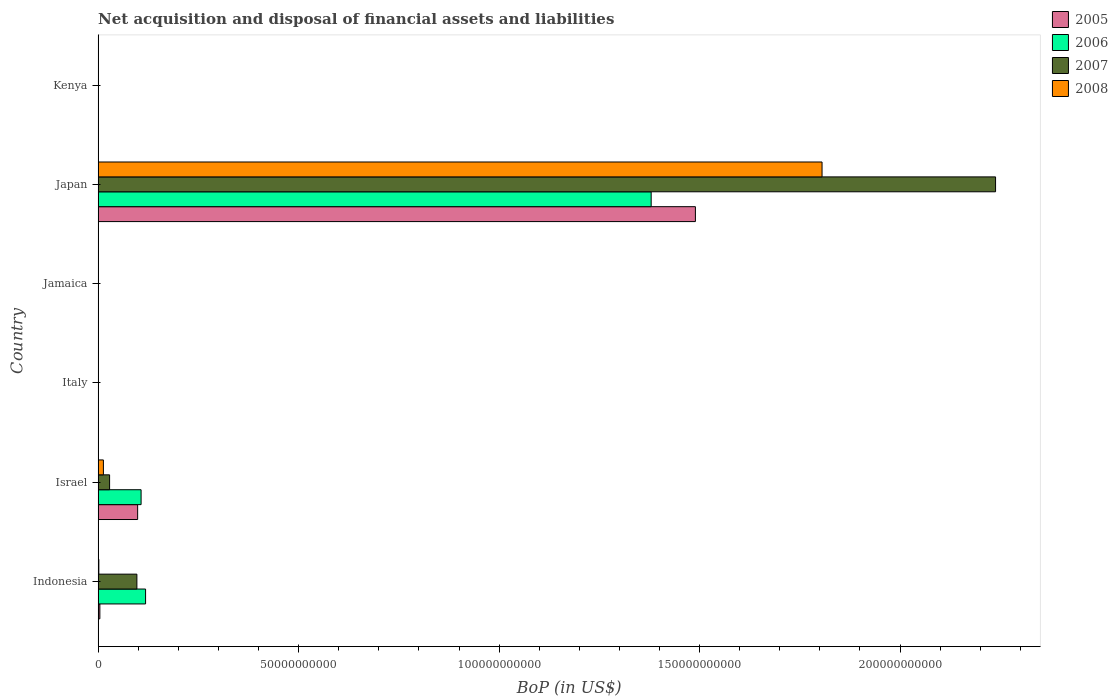How many different coloured bars are there?
Make the answer very short. 4. Are the number of bars on each tick of the Y-axis equal?
Make the answer very short. No. How many bars are there on the 2nd tick from the top?
Your answer should be compact. 4. What is the Balance of Payments in 2008 in Japan?
Make the answer very short. 1.81e+11. Across all countries, what is the maximum Balance of Payments in 2006?
Ensure brevity in your answer.  1.38e+11. Across all countries, what is the minimum Balance of Payments in 2006?
Provide a succinct answer. 0. In which country was the Balance of Payments in 2005 maximum?
Make the answer very short. Japan. What is the total Balance of Payments in 2007 in the graph?
Give a very brief answer. 2.36e+11. What is the difference between the Balance of Payments in 2006 in Israel and that in Japan?
Your answer should be very brief. -1.27e+11. What is the difference between the Balance of Payments in 2007 in Japan and the Balance of Payments in 2006 in Israel?
Ensure brevity in your answer.  2.13e+11. What is the average Balance of Payments in 2008 per country?
Your answer should be compact. 3.03e+1. What is the difference between the Balance of Payments in 2005 and Balance of Payments in 2007 in Israel?
Your answer should be compact. 6.99e+09. What is the difference between the highest and the second highest Balance of Payments in 2008?
Make the answer very short. 1.79e+11. What is the difference between the highest and the lowest Balance of Payments in 2005?
Offer a very short reply. 1.49e+11. In how many countries, is the Balance of Payments in 2007 greater than the average Balance of Payments in 2007 taken over all countries?
Offer a terse response. 1. Is it the case that in every country, the sum of the Balance of Payments in 2005 and Balance of Payments in 2008 is greater than the Balance of Payments in 2007?
Offer a terse response. No. Are all the bars in the graph horizontal?
Make the answer very short. Yes. How many countries are there in the graph?
Provide a succinct answer. 6. Does the graph contain any zero values?
Your response must be concise. Yes. Does the graph contain grids?
Provide a short and direct response. No. What is the title of the graph?
Your answer should be compact. Net acquisition and disposal of financial assets and liabilities. Does "2009" appear as one of the legend labels in the graph?
Ensure brevity in your answer.  No. What is the label or title of the X-axis?
Make the answer very short. BoP (in US$). What is the label or title of the Y-axis?
Your answer should be very brief. Country. What is the BoP (in US$) of 2005 in Indonesia?
Make the answer very short. 4.33e+08. What is the BoP (in US$) of 2006 in Indonesia?
Offer a very short reply. 1.18e+1. What is the BoP (in US$) of 2007 in Indonesia?
Offer a very short reply. 9.67e+09. What is the BoP (in US$) in 2008 in Indonesia?
Give a very brief answer. 1.82e+08. What is the BoP (in US$) of 2005 in Israel?
Offer a terse response. 9.86e+09. What is the BoP (in US$) of 2006 in Israel?
Keep it short and to the point. 1.07e+1. What is the BoP (in US$) in 2007 in Israel?
Keep it short and to the point. 2.86e+09. What is the BoP (in US$) in 2008 in Israel?
Offer a very short reply. 1.32e+09. What is the BoP (in US$) of 2005 in Italy?
Your answer should be compact. 0. What is the BoP (in US$) in 2006 in Italy?
Your answer should be very brief. 0. What is the BoP (in US$) in 2008 in Italy?
Make the answer very short. 0. What is the BoP (in US$) in 2007 in Jamaica?
Keep it short and to the point. 0. What is the BoP (in US$) in 2005 in Japan?
Ensure brevity in your answer.  1.49e+11. What is the BoP (in US$) in 2006 in Japan?
Provide a succinct answer. 1.38e+11. What is the BoP (in US$) of 2007 in Japan?
Your answer should be compact. 2.24e+11. What is the BoP (in US$) in 2008 in Japan?
Your answer should be compact. 1.81e+11. What is the BoP (in US$) of 2005 in Kenya?
Ensure brevity in your answer.  0. What is the BoP (in US$) in 2006 in Kenya?
Your response must be concise. 0. What is the BoP (in US$) in 2008 in Kenya?
Ensure brevity in your answer.  0. Across all countries, what is the maximum BoP (in US$) in 2005?
Provide a short and direct response. 1.49e+11. Across all countries, what is the maximum BoP (in US$) of 2006?
Your answer should be compact. 1.38e+11. Across all countries, what is the maximum BoP (in US$) of 2007?
Your answer should be compact. 2.24e+11. Across all countries, what is the maximum BoP (in US$) in 2008?
Keep it short and to the point. 1.81e+11. Across all countries, what is the minimum BoP (in US$) in 2006?
Offer a very short reply. 0. Across all countries, what is the minimum BoP (in US$) in 2008?
Your answer should be compact. 0. What is the total BoP (in US$) in 2005 in the graph?
Ensure brevity in your answer.  1.59e+11. What is the total BoP (in US$) in 2006 in the graph?
Your answer should be very brief. 1.60e+11. What is the total BoP (in US$) of 2007 in the graph?
Provide a short and direct response. 2.36e+11. What is the total BoP (in US$) of 2008 in the graph?
Give a very brief answer. 1.82e+11. What is the difference between the BoP (in US$) of 2005 in Indonesia and that in Israel?
Offer a very short reply. -9.42e+09. What is the difference between the BoP (in US$) in 2006 in Indonesia and that in Israel?
Provide a short and direct response. 1.12e+09. What is the difference between the BoP (in US$) in 2007 in Indonesia and that in Israel?
Offer a very short reply. 6.81e+09. What is the difference between the BoP (in US$) of 2008 in Indonesia and that in Israel?
Your answer should be very brief. -1.14e+09. What is the difference between the BoP (in US$) of 2005 in Indonesia and that in Japan?
Offer a very short reply. -1.49e+11. What is the difference between the BoP (in US$) in 2006 in Indonesia and that in Japan?
Your response must be concise. -1.26e+11. What is the difference between the BoP (in US$) in 2007 in Indonesia and that in Japan?
Your response must be concise. -2.14e+11. What is the difference between the BoP (in US$) of 2008 in Indonesia and that in Japan?
Your answer should be very brief. -1.80e+11. What is the difference between the BoP (in US$) of 2005 in Israel and that in Japan?
Provide a succinct answer. -1.39e+11. What is the difference between the BoP (in US$) in 2006 in Israel and that in Japan?
Offer a very short reply. -1.27e+11. What is the difference between the BoP (in US$) of 2007 in Israel and that in Japan?
Your answer should be very brief. -2.21e+11. What is the difference between the BoP (in US$) in 2008 in Israel and that in Japan?
Provide a short and direct response. -1.79e+11. What is the difference between the BoP (in US$) of 2005 in Indonesia and the BoP (in US$) of 2006 in Israel?
Your response must be concise. -1.03e+1. What is the difference between the BoP (in US$) of 2005 in Indonesia and the BoP (in US$) of 2007 in Israel?
Your response must be concise. -2.43e+09. What is the difference between the BoP (in US$) of 2005 in Indonesia and the BoP (in US$) of 2008 in Israel?
Keep it short and to the point. -8.85e+08. What is the difference between the BoP (in US$) in 2006 in Indonesia and the BoP (in US$) in 2007 in Israel?
Your answer should be compact. 8.97e+09. What is the difference between the BoP (in US$) in 2006 in Indonesia and the BoP (in US$) in 2008 in Israel?
Give a very brief answer. 1.05e+1. What is the difference between the BoP (in US$) of 2007 in Indonesia and the BoP (in US$) of 2008 in Israel?
Offer a terse response. 8.35e+09. What is the difference between the BoP (in US$) of 2005 in Indonesia and the BoP (in US$) of 2006 in Japan?
Offer a terse response. -1.37e+11. What is the difference between the BoP (in US$) in 2005 in Indonesia and the BoP (in US$) in 2007 in Japan?
Offer a terse response. -2.23e+11. What is the difference between the BoP (in US$) in 2005 in Indonesia and the BoP (in US$) in 2008 in Japan?
Offer a very short reply. -1.80e+11. What is the difference between the BoP (in US$) of 2006 in Indonesia and the BoP (in US$) of 2007 in Japan?
Your answer should be very brief. -2.12e+11. What is the difference between the BoP (in US$) in 2006 in Indonesia and the BoP (in US$) in 2008 in Japan?
Your answer should be very brief. -1.69e+11. What is the difference between the BoP (in US$) of 2007 in Indonesia and the BoP (in US$) of 2008 in Japan?
Offer a terse response. -1.71e+11. What is the difference between the BoP (in US$) in 2005 in Israel and the BoP (in US$) in 2006 in Japan?
Give a very brief answer. -1.28e+11. What is the difference between the BoP (in US$) in 2005 in Israel and the BoP (in US$) in 2007 in Japan?
Ensure brevity in your answer.  -2.14e+11. What is the difference between the BoP (in US$) in 2005 in Israel and the BoP (in US$) in 2008 in Japan?
Offer a terse response. -1.71e+11. What is the difference between the BoP (in US$) of 2006 in Israel and the BoP (in US$) of 2007 in Japan?
Your response must be concise. -2.13e+11. What is the difference between the BoP (in US$) of 2006 in Israel and the BoP (in US$) of 2008 in Japan?
Your answer should be compact. -1.70e+11. What is the difference between the BoP (in US$) of 2007 in Israel and the BoP (in US$) of 2008 in Japan?
Your answer should be compact. -1.78e+11. What is the average BoP (in US$) of 2005 per country?
Give a very brief answer. 2.65e+1. What is the average BoP (in US$) in 2006 per country?
Make the answer very short. 2.67e+1. What is the average BoP (in US$) of 2007 per country?
Give a very brief answer. 3.94e+1. What is the average BoP (in US$) in 2008 per country?
Give a very brief answer. 3.03e+1. What is the difference between the BoP (in US$) in 2005 and BoP (in US$) in 2006 in Indonesia?
Your answer should be very brief. -1.14e+1. What is the difference between the BoP (in US$) of 2005 and BoP (in US$) of 2007 in Indonesia?
Offer a terse response. -9.24e+09. What is the difference between the BoP (in US$) in 2005 and BoP (in US$) in 2008 in Indonesia?
Provide a short and direct response. 2.51e+08. What is the difference between the BoP (in US$) of 2006 and BoP (in US$) of 2007 in Indonesia?
Keep it short and to the point. 2.16e+09. What is the difference between the BoP (in US$) in 2006 and BoP (in US$) in 2008 in Indonesia?
Provide a succinct answer. 1.17e+1. What is the difference between the BoP (in US$) of 2007 and BoP (in US$) of 2008 in Indonesia?
Offer a very short reply. 9.49e+09. What is the difference between the BoP (in US$) of 2005 and BoP (in US$) of 2006 in Israel?
Make the answer very short. -8.59e+08. What is the difference between the BoP (in US$) of 2005 and BoP (in US$) of 2007 in Israel?
Offer a terse response. 6.99e+09. What is the difference between the BoP (in US$) of 2005 and BoP (in US$) of 2008 in Israel?
Provide a short and direct response. 8.54e+09. What is the difference between the BoP (in US$) of 2006 and BoP (in US$) of 2007 in Israel?
Offer a very short reply. 7.85e+09. What is the difference between the BoP (in US$) of 2006 and BoP (in US$) of 2008 in Israel?
Keep it short and to the point. 9.40e+09. What is the difference between the BoP (in US$) of 2007 and BoP (in US$) of 2008 in Israel?
Your answer should be compact. 1.54e+09. What is the difference between the BoP (in US$) of 2005 and BoP (in US$) of 2006 in Japan?
Offer a terse response. 1.10e+1. What is the difference between the BoP (in US$) of 2005 and BoP (in US$) of 2007 in Japan?
Provide a succinct answer. -7.49e+1. What is the difference between the BoP (in US$) in 2005 and BoP (in US$) in 2008 in Japan?
Provide a succinct answer. -3.16e+1. What is the difference between the BoP (in US$) of 2006 and BoP (in US$) of 2007 in Japan?
Give a very brief answer. -8.59e+1. What is the difference between the BoP (in US$) in 2006 and BoP (in US$) in 2008 in Japan?
Offer a very short reply. -4.26e+1. What is the difference between the BoP (in US$) in 2007 and BoP (in US$) in 2008 in Japan?
Your response must be concise. 4.33e+1. What is the ratio of the BoP (in US$) in 2005 in Indonesia to that in Israel?
Provide a short and direct response. 0.04. What is the ratio of the BoP (in US$) of 2006 in Indonesia to that in Israel?
Provide a succinct answer. 1.1. What is the ratio of the BoP (in US$) of 2007 in Indonesia to that in Israel?
Your answer should be compact. 3.38. What is the ratio of the BoP (in US$) of 2008 in Indonesia to that in Israel?
Your answer should be compact. 0.14. What is the ratio of the BoP (in US$) in 2005 in Indonesia to that in Japan?
Your response must be concise. 0. What is the ratio of the BoP (in US$) in 2006 in Indonesia to that in Japan?
Ensure brevity in your answer.  0.09. What is the ratio of the BoP (in US$) in 2007 in Indonesia to that in Japan?
Offer a terse response. 0.04. What is the ratio of the BoP (in US$) of 2005 in Israel to that in Japan?
Keep it short and to the point. 0.07. What is the ratio of the BoP (in US$) in 2006 in Israel to that in Japan?
Provide a succinct answer. 0.08. What is the ratio of the BoP (in US$) of 2007 in Israel to that in Japan?
Make the answer very short. 0.01. What is the ratio of the BoP (in US$) in 2008 in Israel to that in Japan?
Ensure brevity in your answer.  0.01. What is the difference between the highest and the second highest BoP (in US$) of 2005?
Make the answer very short. 1.39e+11. What is the difference between the highest and the second highest BoP (in US$) in 2006?
Ensure brevity in your answer.  1.26e+11. What is the difference between the highest and the second highest BoP (in US$) of 2007?
Your answer should be very brief. 2.14e+11. What is the difference between the highest and the second highest BoP (in US$) in 2008?
Ensure brevity in your answer.  1.79e+11. What is the difference between the highest and the lowest BoP (in US$) in 2005?
Give a very brief answer. 1.49e+11. What is the difference between the highest and the lowest BoP (in US$) of 2006?
Your answer should be very brief. 1.38e+11. What is the difference between the highest and the lowest BoP (in US$) of 2007?
Provide a succinct answer. 2.24e+11. What is the difference between the highest and the lowest BoP (in US$) in 2008?
Give a very brief answer. 1.81e+11. 